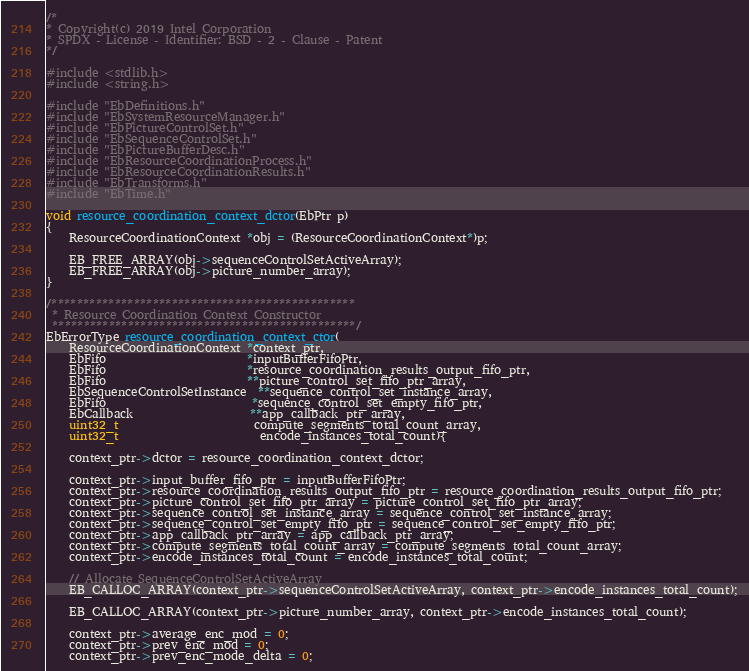<code> <loc_0><loc_0><loc_500><loc_500><_C_>/*
* Copyright(c) 2019 Intel Corporation
* SPDX - License - Identifier: BSD - 2 - Clause - Patent
*/

#include <stdlib.h>
#include <string.h>

#include "EbDefinitions.h"
#include "EbSystemResourceManager.h"
#include "EbPictureControlSet.h"
#include "EbSequenceControlSet.h"
#include "EbPictureBufferDesc.h"
#include "EbResourceCoordinationProcess.h"
#include "EbResourceCoordinationResults.h"
#include "EbTransforms.h"
#include "EbTime.h"

void resource_coordination_context_dctor(EbPtr p)
{
    ResourceCoordinationContext *obj = (ResourceCoordinationContext*)p;

    EB_FREE_ARRAY(obj->sequenceControlSetActiveArray);
    EB_FREE_ARRAY(obj->picture_number_array);
}

/************************************************
 * Resource Coordination Context Constructor
 ************************************************/
EbErrorType resource_coordination_context_ctor(
    ResourceCoordinationContext *context_ptr,
    EbFifo                        *inputBufferFifoPtr,
    EbFifo                        *resource_coordination_results_output_fifo_ptr,
    EbFifo                        **picture_control_set_fifo_ptr_array,
    EbSequenceControlSetInstance  **sequence_control_set_instance_array,
    EbFifo                         *sequence_control_set_empty_fifo_ptr,
    EbCallback                    **app_callback_ptr_array,
    uint32_t                       compute_segments_total_count_array,
    uint32_t                        encode_instances_total_count){

    context_ptr->dctor = resource_coordination_context_dctor;

    context_ptr->input_buffer_fifo_ptr = inputBufferFifoPtr;
    context_ptr->resource_coordination_results_output_fifo_ptr = resource_coordination_results_output_fifo_ptr;
    context_ptr->picture_control_set_fifo_ptr_array = picture_control_set_fifo_ptr_array;
    context_ptr->sequence_control_set_instance_array = sequence_control_set_instance_array;
    context_ptr->sequence_control_set_empty_fifo_ptr = sequence_control_set_empty_fifo_ptr;
    context_ptr->app_callback_ptr_array = app_callback_ptr_array;
    context_ptr->compute_segments_total_count_array = compute_segments_total_count_array;
    context_ptr->encode_instances_total_count = encode_instances_total_count;

    // Allocate SequenceControlSetActiveArray
    EB_CALLOC_ARRAY(context_ptr->sequenceControlSetActiveArray, context_ptr->encode_instances_total_count);

    EB_CALLOC_ARRAY(context_ptr->picture_number_array, context_ptr->encode_instances_total_count);

    context_ptr->average_enc_mod = 0;
    context_ptr->prev_enc_mod = 0;
    context_ptr->prev_enc_mode_delta = 0;</code> 